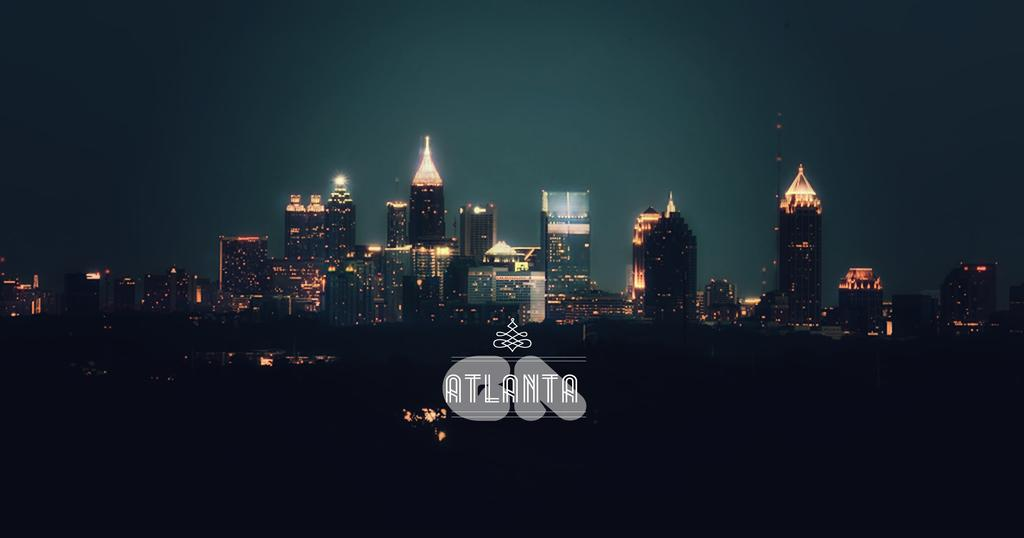<image>
Present a compact description of the photo's key features. A night time scene shows the illuminated skyline of Atlanta. 